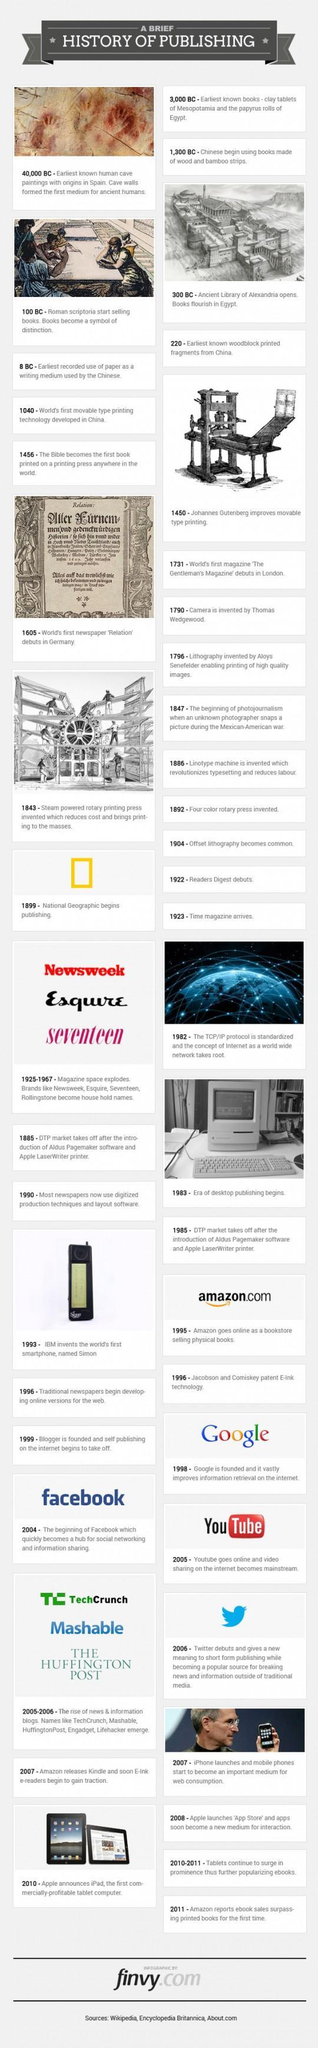What is the colour of the National Geographic logo- red, blue or yellow?
Answer the question with a short phrase. yellow 